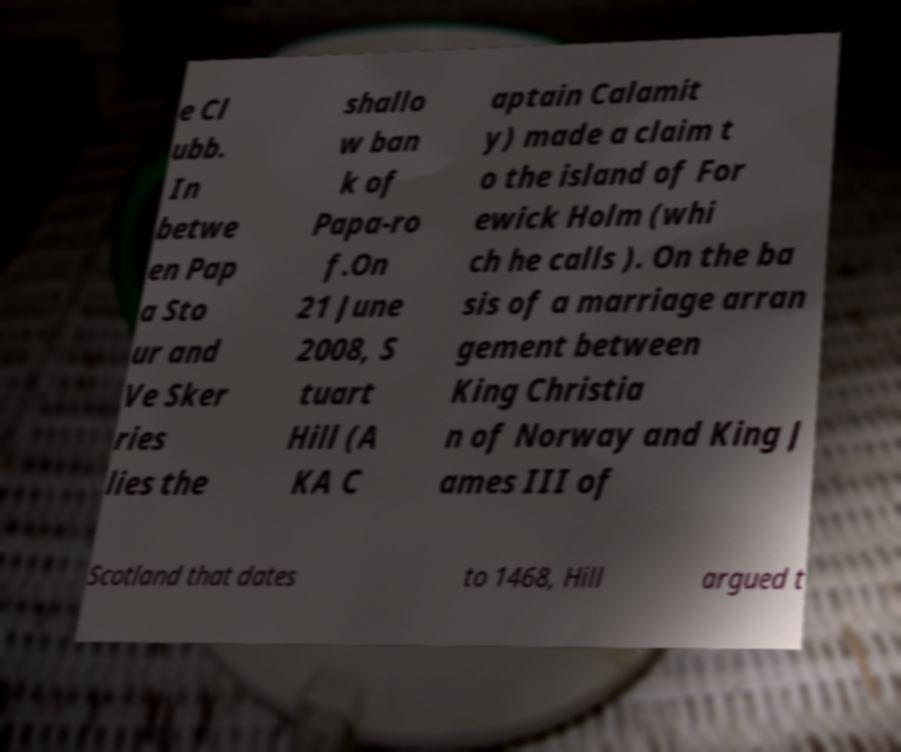Could you extract and type out the text from this image? e Cl ubb. In betwe en Pap a Sto ur and Ve Sker ries lies the shallo w ban k of Papa-ro f.On 21 June 2008, S tuart Hill (A KA C aptain Calamit y) made a claim t o the island of For ewick Holm (whi ch he calls ). On the ba sis of a marriage arran gement between King Christia n of Norway and King J ames III of Scotland that dates to 1468, Hill argued t 